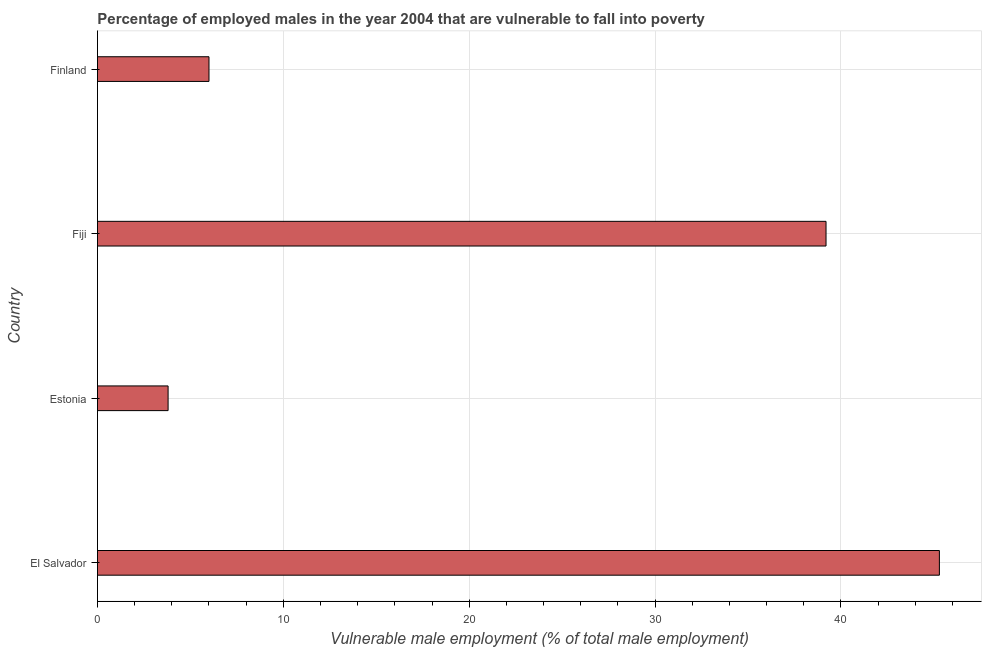Does the graph contain any zero values?
Ensure brevity in your answer.  No. Does the graph contain grids?
Offer a very short reply. Yes. What is the title of the graph?
Make the answer very short. Percentage of employed males in the year 2004 that are vulnerable to fall into poverty. What is the label or title of the X-axis?
Make the answer very short. Vulnerable male employment (% of total male employment). What is the label or title of the Y-axis?
Your answer should be compact. Country. What is the percentage of employed males who are vulnerable to fall into poverty in Finland?
Offer a very short reply. 6. Across all countries, what is the maximum percentage of employed males who are vulnerable to fall into poverty?
Your answer should be compact. 45.3. Across all countries, what is the minimum percentage of employed males who are vulnerable to fall into poverty?
Offer a very short reply. 3.8. In which country was the percentage of employed males who are vulnerable to fall into poverty maximum?
Provide a succinct answer. El Salvador. In which country was the percentage of employed males who are vulnerable to fall into poverty minimum?
Your answer should be compact. Estonia. What is the sum of the percentage of employed males who are vulnerable to fall into poverty?
Your answer should be very brief. 94.3. What is the average percentage of employed males who are vulnerable to fall into poverty per country?
Your answer should be compact. 23.57. What is the median percentage of employed males who are vulnerable to fall into poverty?
Offer a terse response. 22.6. What is the ratio of the percentage of employed males who are vulnerable to fall into poverty in Estonia to that in Finland?
Offer a very short reply. 0.63. Is the percentage of employed males who are vulnerable to fall into poverty in El Salvador less than that in Finland?
Offer a very short reply. No. Is the difference between the percentage of employed males who are vulnerable to fall into poverty in El Salvador and Estonia greater than the difference between any two countries?
Your answer should be compact. Yes. What is the difference between the highest and the lowest percentage of employed males who are vulnerable to fall into poverty?
Provide a short and direct response. 41.5. How many bars are there?
Provide a succinct answer. 4. How many countries are there in the graph?
Offer a terse response. 4. What is the difference between two consecutive major ticks on the X-axis?
Your answer should be very brief. 10. Are the values on the major ticks of X-axis written in scientific E-notation?
Offer a very short reply. No. What is the Vulnerable male employment (% of total male employment) of El Salvador?
Your response must be concise. 45.3. What is the Vulnerable male employment (% of total male employment) in Estonia?
Make the answer very short. 3.8. What is the Vulnerable male employment (% of total male employment) in Fiji?
Provide a short and direct response. 39.2. What is the Vulnerable male employment (% of total male employment) in Finland?
Make the answer very short. 6. What is the difference between the Vulnerable male employment (% of total male employment) in El Salvador and Estonia?
Your response must be concise. 41.5. What is the difference between the Vulnerable male employment (% of total male employment) in El Salvador and Finland?
Offer a very short reply. 39.3. What is the difference between the Vulnerable male employment (% of total male employment) in Estonia and Fiji?
Provide a short and direct response. -35.4. What is the difference between the Vulnerable male employment (% of total male employment) in Estonia and Finland?
Keep it short and to the point. -2.2. What is the difference between the Vulnerable male employment (% of total male employment) in Fiji and Finland?
Your answer should be compact. 33.2. What is the ratio of the Vulnerable male employment (% of total male employment) in El Salvador to that in Estonia?
Make the answer very short. 11.92. What is the ratio of the Vulnerable male employment (% of total male employment) in El Salvador to that in Fiji?
Your response must be concise. 1.16. What is the ratio of the Vulnerable male employment (% of total male employment) in El Salvador to that in Finland?
Give a very brief answer. 7.55. What is the ratio of the Vulnerable male employment (% of total male employment) in Estonia to that in Fiji?
Keep it short and to the point. 0.1. What is the ratio of the Vulnerable male employment (% of total male employment) in Estonia to that in Finland?
Your answer should be very brief. 0.63. What is the ratio of the Vulnerable male employment (% of total male employment) in Fiji to that in Finland?
Give a very brief answer. 6.53. 